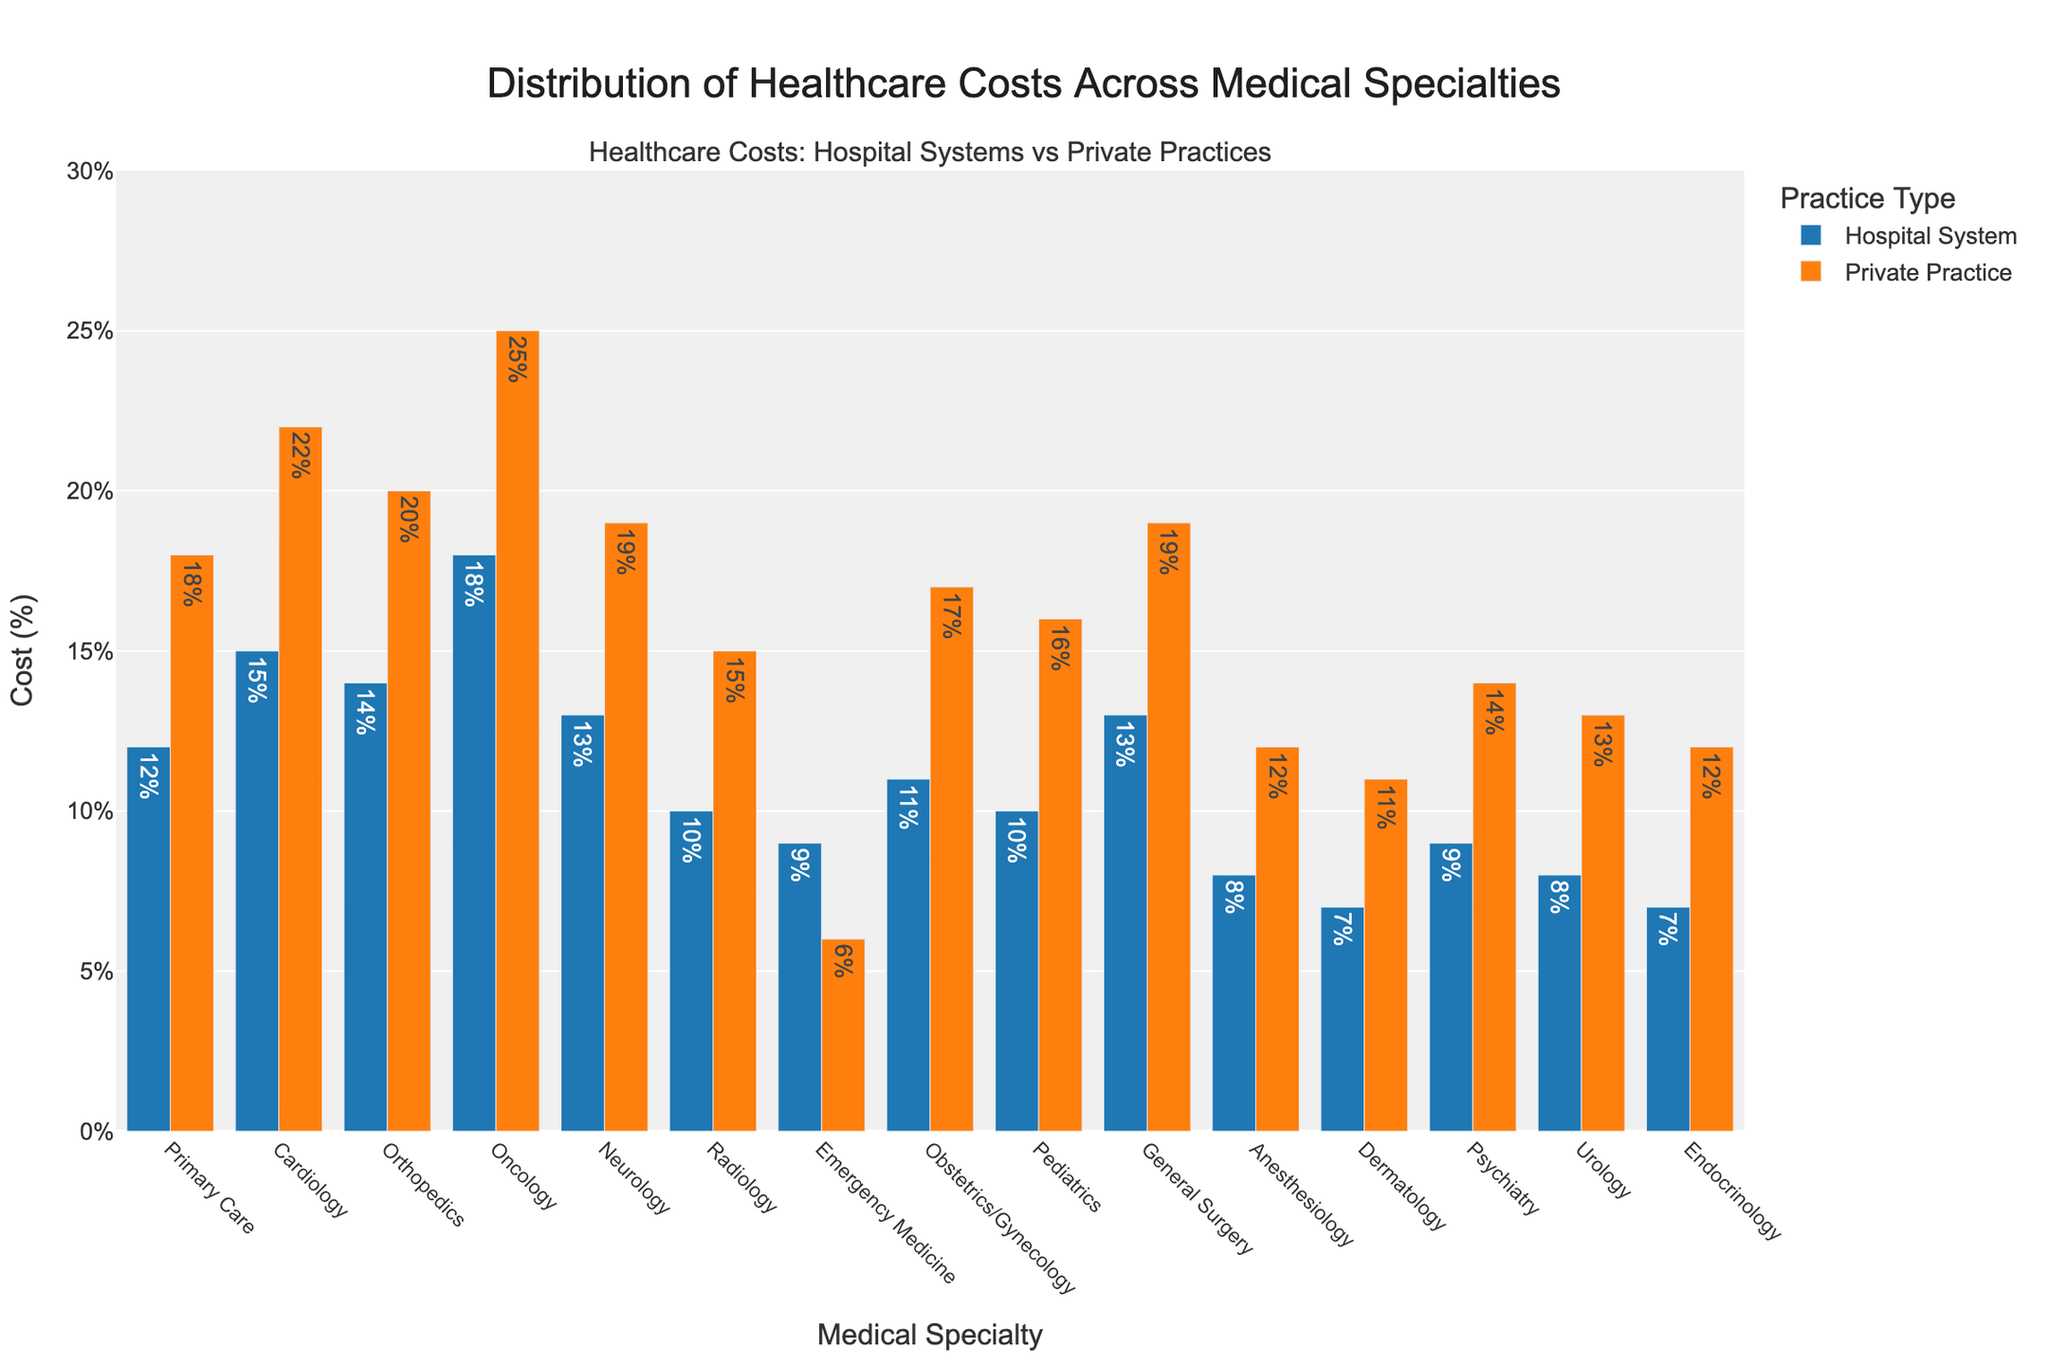Which specialty has the highest cost in private practices? By looking at the heights of the bars in the private practice category, Oncology has the highest cost percentage among all specialties.
Answer: Oncology How much greater is the cardiology cost in private practices compared to hospital systems? The bar for cardiology in private practices shows 22%, while in hospital systems it shows 15%. The difference is calculated as 22% - 15% = 7%.
Answer: 7% Which practice type has the lower cost in dermatology and by how much? For dermatology, the cost in hospital systems is 7% and in private practices is 11%. The difference is 11% - 7% = 4%.
Answer: Hospital system, 4% What is the average cost percentage for neurology and emergency medicine across both practice types? Average is calculated by summing the costs in both practice types and then dividing by the number of entries. For neurology, it's (13% + 19%) / 2 = 16%. For emergency medicine, it's (9% + 6%) / 2 = 7.5%. Thus, the combined average is (16% + 7.5%) / 2 = 11.75%.
Answer: 11.75% In which specialty is the difference between hospital system costs and private practice costs smallest? By examining the heights of the bars, Emergency Medicine has the smallest difference with 9% for hospital systems and 6% for private practices, which gives a difference of 3%.
Answer: Emergency Medicine Are there any specialties where the private practice cost is lower than the hospital system cost? By comparing the heights of the bars, in Emergency Medicine, the cost is 6% for private practices and 9% for hospital systems, meaning private practice cost is indeed lower.
Answer: Yes, Emergency Medicine What is the total cost percentage for oncology across both practice types? The total cost is the sum of the individual costs for hospitals and private practices in oncology, which is 18% + 25% = 43%.
Answer: 43% Which specialty has the closest costs in both practice types? By comparing differences, Primary Care and Emergency Medicine have the closest costs; however, Emergency Medicine is smaller with a cost difference of 3% compared to Primary Care's 6% (18% - 12%).
Answer: Emergency Medicine Which specialty in hospital systems has the same cost percentage as anesthesiology in private practices? The bar for anesthesiology in private practices shows 12%, the same as primary care in hospital systems, corresponding to 12%.
Answer: Primary Care 